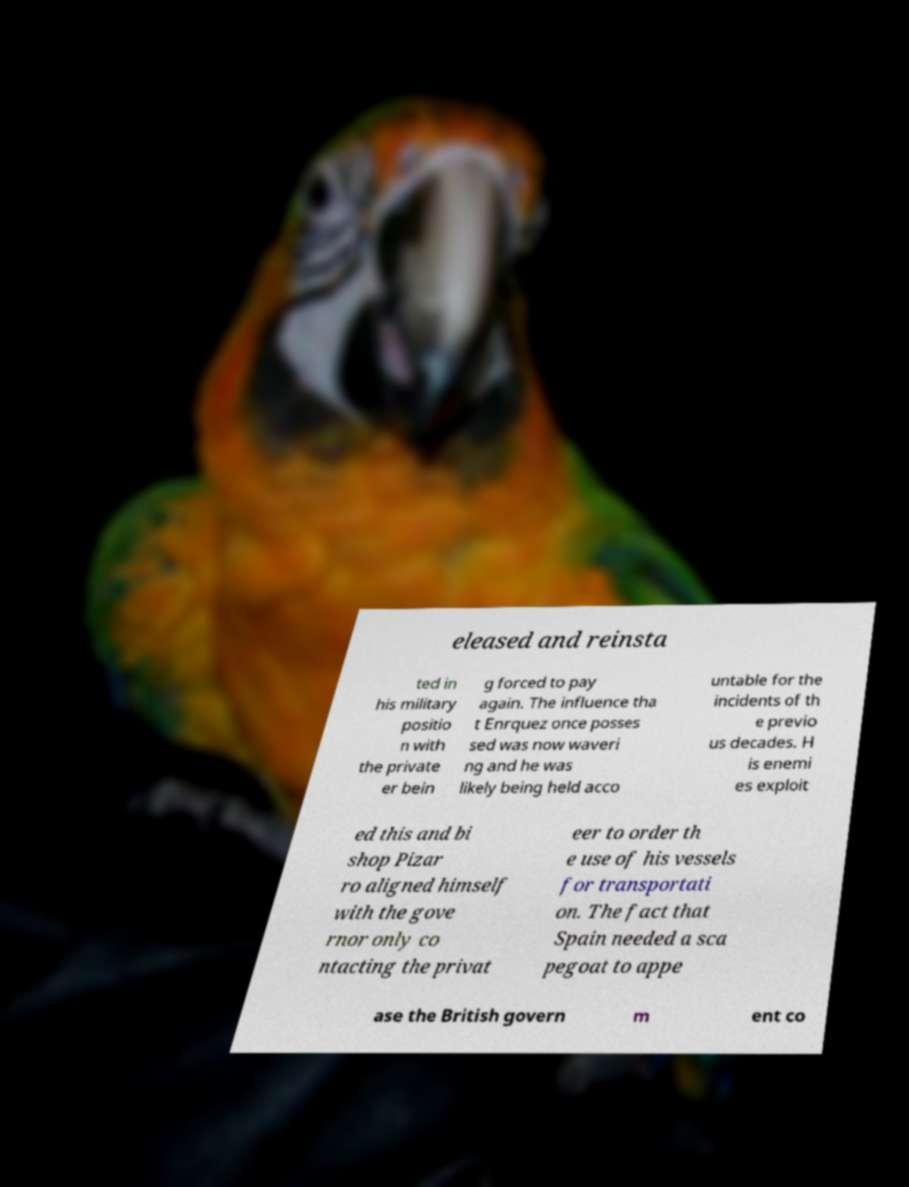Can you read and provide the text displayed in the image?This photo seems to have some interesting text. Can you extract and type it out for me? eleased and reinsta ted in his military positio n with the private er bein g forced to pay again. The influence tha t Enrquez once posses sed was now waveri ng and he was likely being held acco untable for the incidents of th e previo us decades. H is enemi es exploit ed this and bi shop Pizar ro aligned himself with the gove rnor only co ntacting the privat eer to order th e use of his vessels for transportati on. The fact that Spain needed a sca pegoat to appe ase the British govern m ent co 